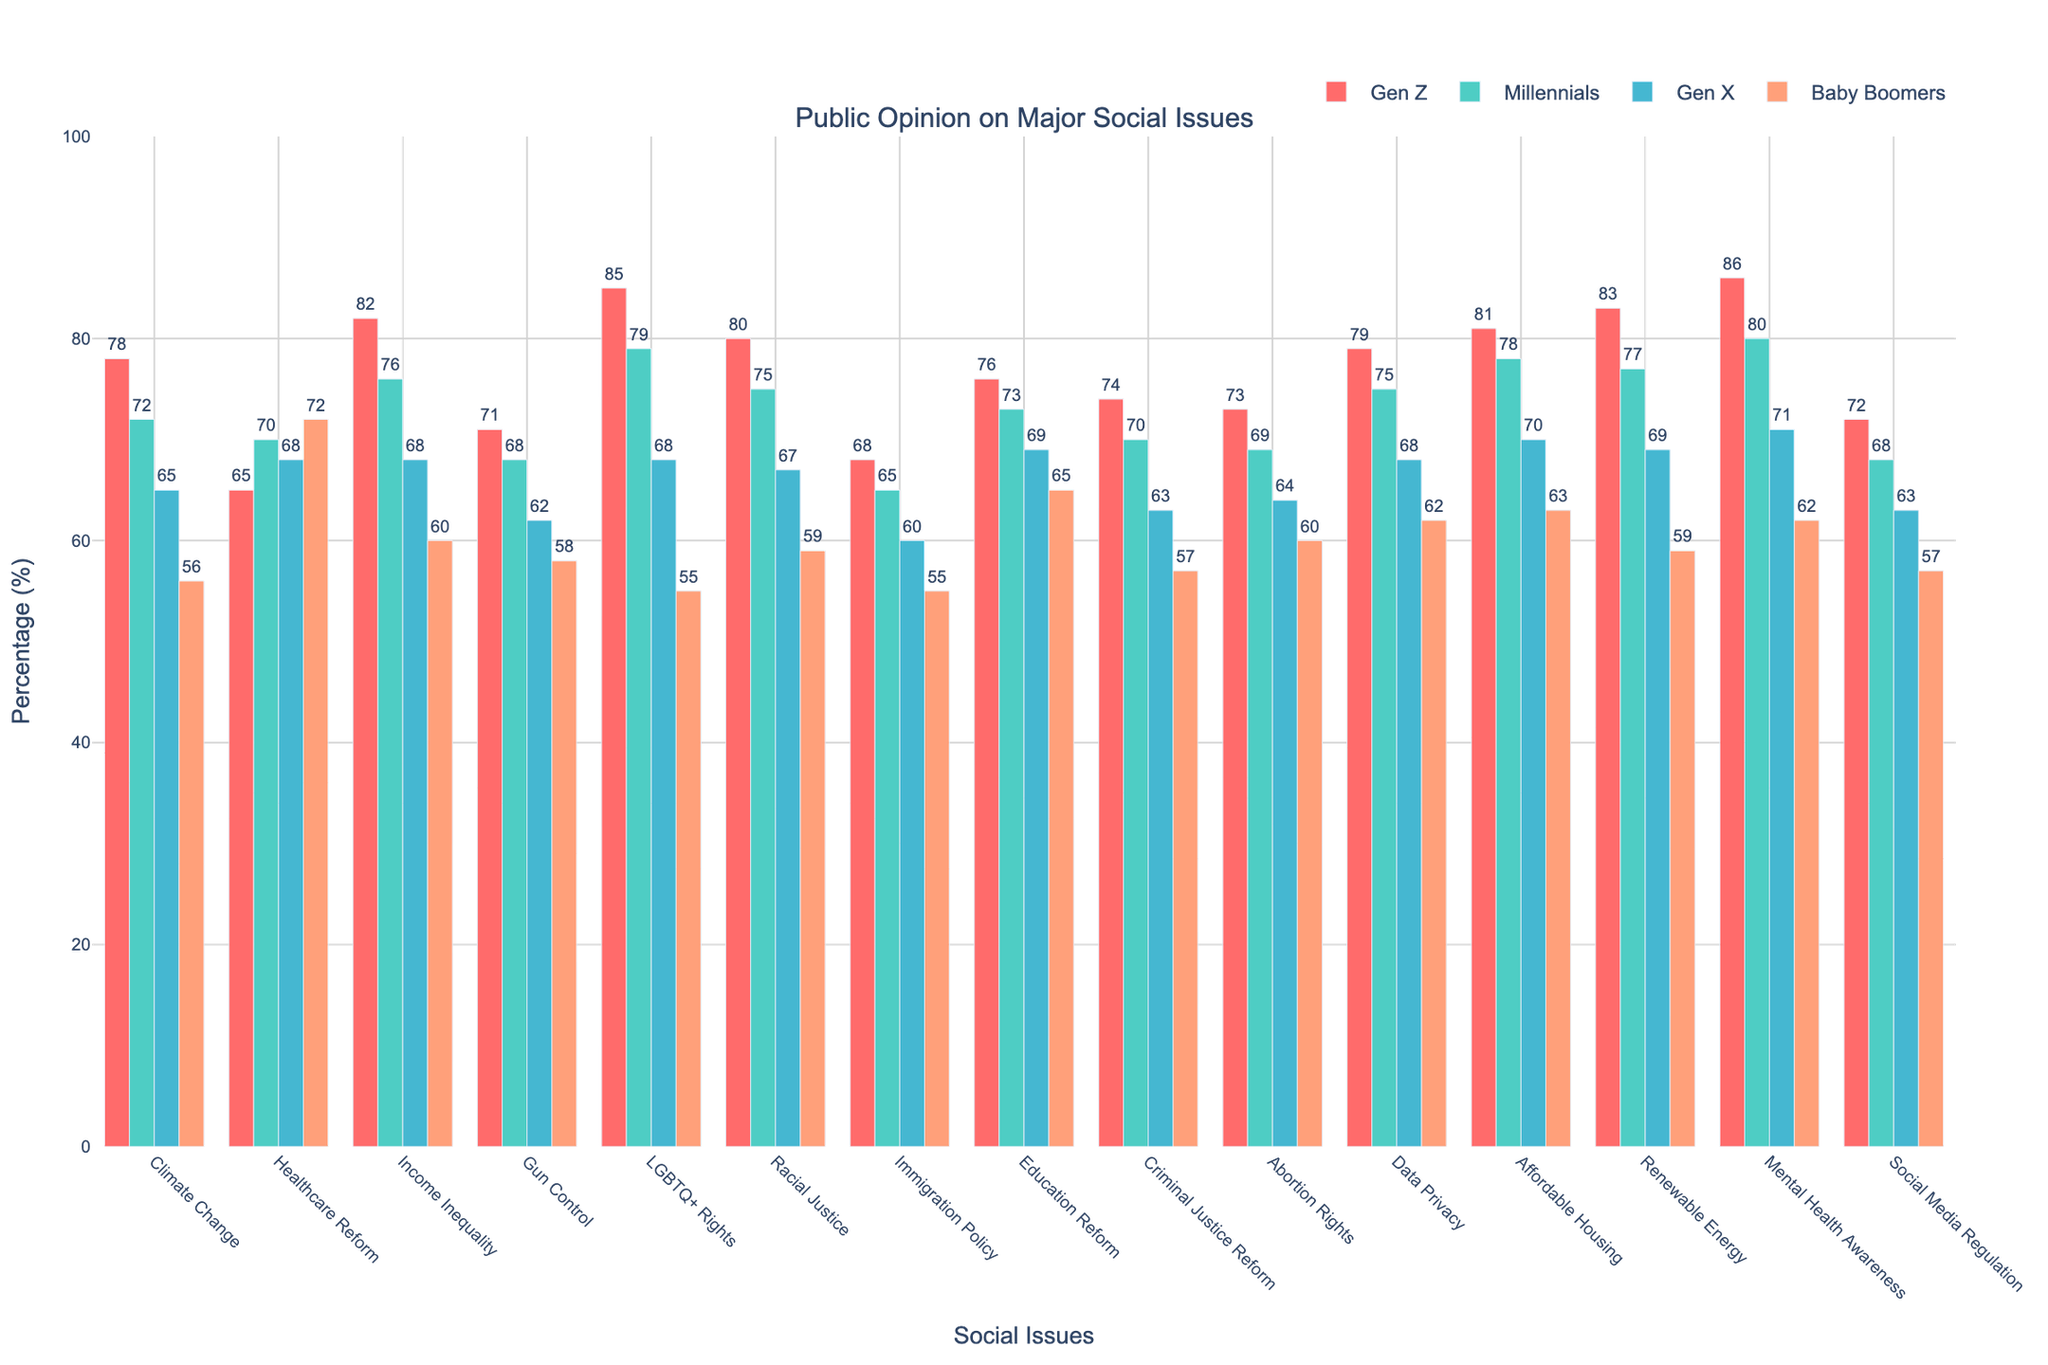What social issue has the highest percentage of support among Gen Z? The bar for 'Mental Health Awareness' in the Gen Z section is tallest and clearly marked at 86%, indicating it has the highest support.
Answer: Mental Health Awareness at 86% How does Millennial support for Climate Change compare to Gen Z? The chart shows Gen Z support at 78% and Millennial support at 72%. To compare, Gen Z's support for Climate Change is higher by 6%.
Answer: Gen Z support is higher by 6% Which generation shows the least support for LGBTQ+ Rights? Looking at the bars for LGBTQ+ Rights, the Baby Boomers category is lowest at 55%, clearly showing the least support.
Answer: Baby Boomers at 55% What is the difference in support for Income Inequality between Gen X and Baby Boomers? Gen X shows 68% support while Baby Boomers show 60%. Subtracting these values gives 68% - 60% = 8%.
Answer: 8% Which social issue has the most uniform support across all generations? Observing the lengths of the bars, Healthcare Reform has the least variation, with values close to each other (65, 70, 68, 72).
Answer: Healthcare Reform By how much does Gen Z's support for Renewable Energy surpass Gen X's? Gen Z support is 83% while Gen X support is 69%. Subtracting, 83% - 69% = 14%.
Answer: 14% What is the average level of support for Education Reform across all generations? The percentages are 76 (Gen Z) + 73 (Millennials) + 69 (Gen X) + 65 (Baby Boomers). Sum these values: 76 + 73 + 69 + 65 = 283. Then divide by 4 generations: 283 / 4 = 70.75%.
Answer: 70.75% Which generational group shows the highest support for Gun Control and by how much is it higher than the group with the least support? Gen Z shows the highest support for Gun Control at 71%, while Baby Boomers show the least at 58%. The difference is 71% - 58% = 13%.
Answer: Gen Z by 13% For which social issues is support greater than 80% among Gen Z? Bars showing more than 80% for Gen Z include LGBTQ+ Rights (85%), Income Inequality (82%), Affordable Housing (81%), Renewable Energy (83%), Mental Health Awareness (86%), and Racial Justice (80%).
Answer: LGBTQ+ Rights, Income Inequality, Affordable Housing, Renewable Energy, Mental Health Awareness, Racial Justice 